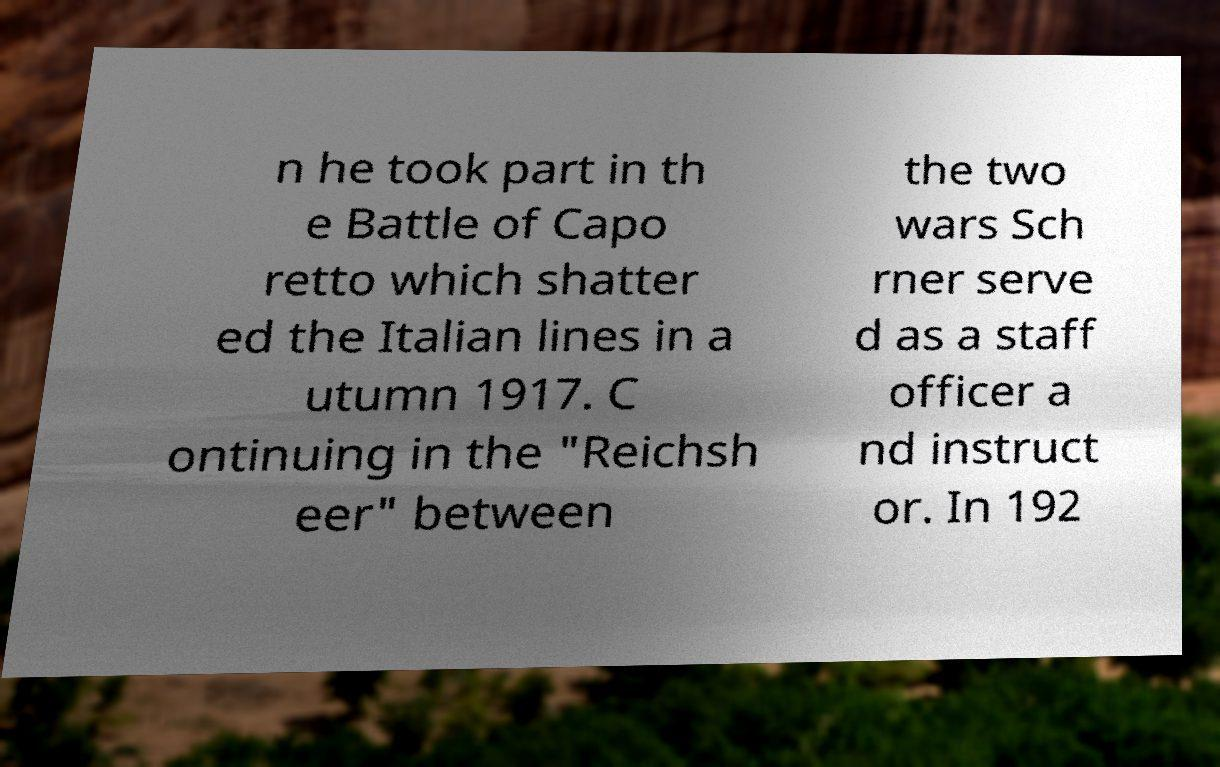Please read and relay the text visible in this image. What does it say? n he took part in th e Battle of Capo retto which shatter ed the Italian lines in a utumn 1917. C ontinuing in the "Reichsh eer" between the two wars Sch rner serve d as a staff officer a nd instruct or. In 192 